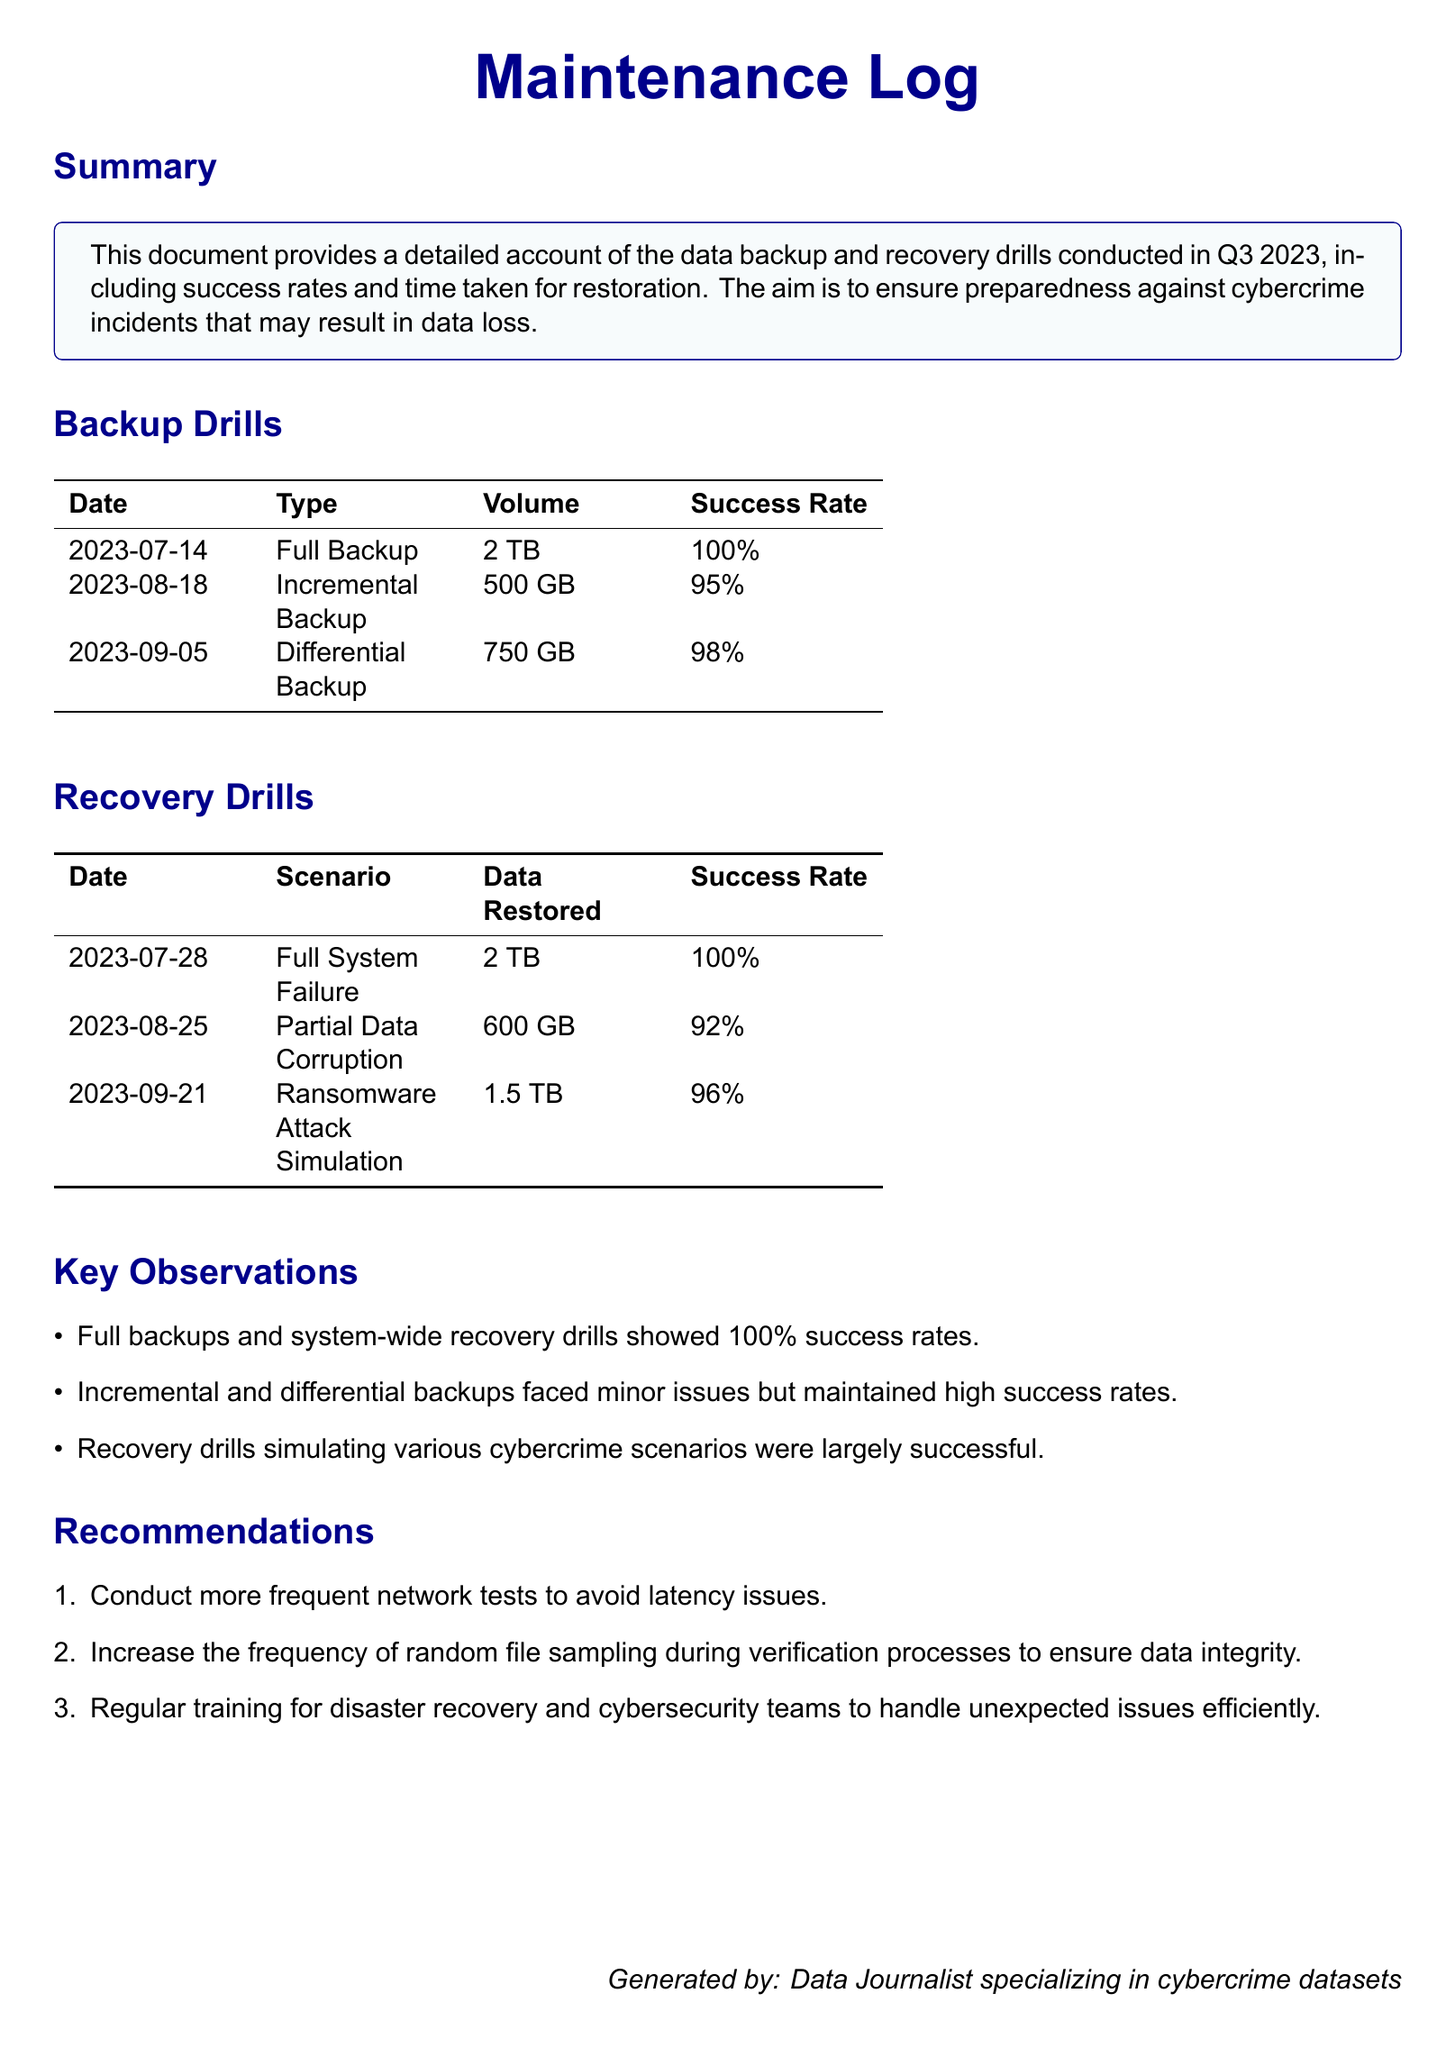What was the date of the full backup? The date of the full backup is mentioned in the Backup Drills section of the document, which states "2023-07-14".
Answer: 2023-07-14 What type of backup had the highest success rate? The Backup Drills table lists the success rates, with 'Full Backup' showing a rate of "100%".
Answer: Full Backup How much data was restored during the ransomware attack simulation? The Recovery Drills section specifies "1.5 TB" was restored during the ransomware attack simulation.
Answer: 1.5 TB What was the success rate for the partial data corruption recovery drill? The Recovery Drills table shows the success rate for 'Partial Data Corruption' is "92%".
Answer: 92% Which recommendation suggests increasing the frequency of checks? The recommendations include a suggestion about verifying data integrity more frequently, specifically stating to "increase the frequency of random file sampling."
Answer: Increase the frequency of random file sampling How many recovery scenarios were conducted? The Recovery Drills section lists three distinct scenarios showcasing data recovery drills, so the total is three.
Answer: Three Which backup type faced minor issues but maintained high success rates? The Key Observations mention that 'Incremental and differential backups faced minor issues but maintained high success rates.'
Answer: Incremental and differential backups What is the volume of data involved in the differential backup? The data volume for the differential backup is listed in the Backup Drills table, which states "750 GB".
Answer: 750 GB 